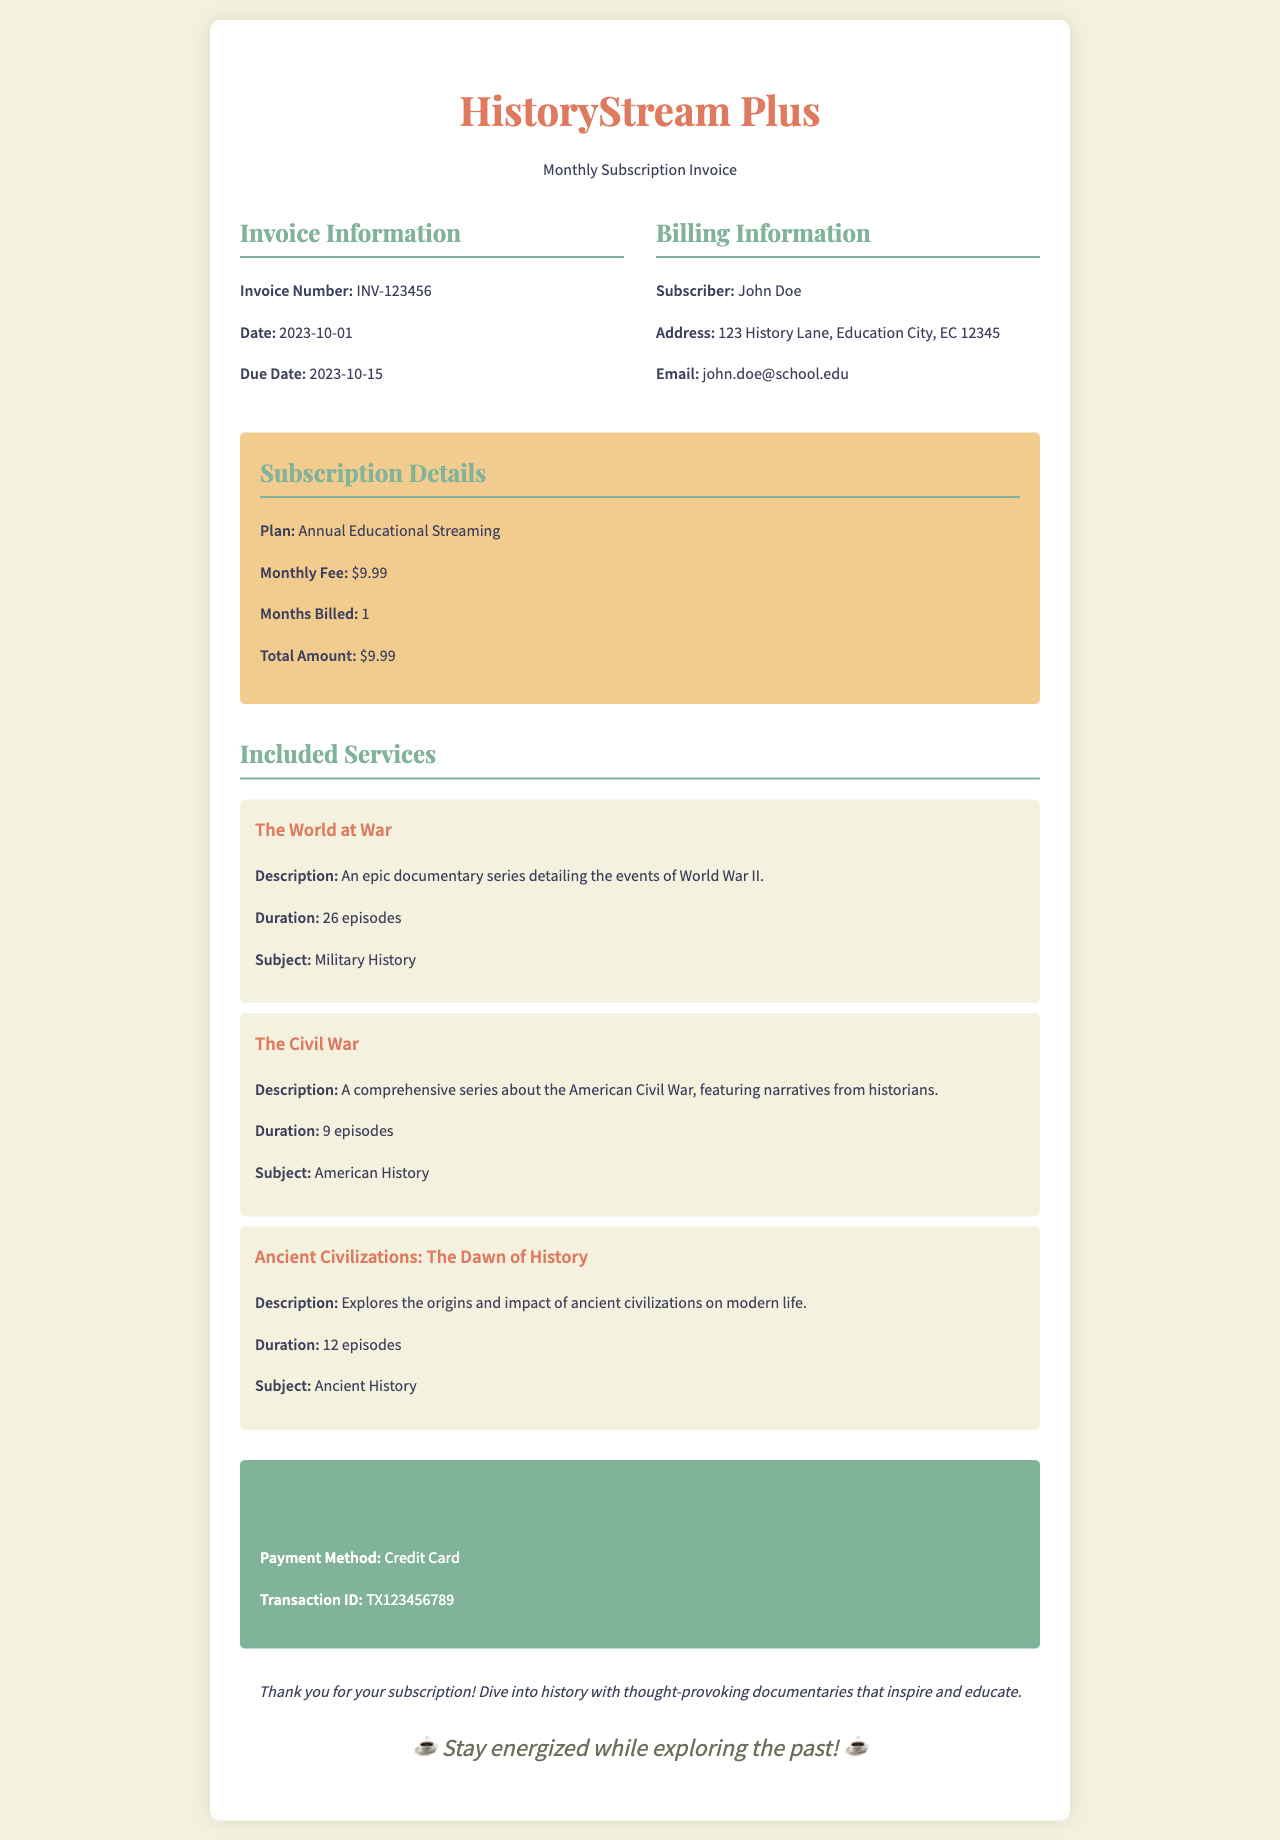What is the invoice number? The invoice number is a unique identifier for the invoice provided in the document.
Answer: INV-123456 What is the total amount due? The total amount due is stated in the subscription details section of the invoice.
Answer: $9.99 Who is the subscriber? The subscriber's name can be found in the billing information section.
Answer: John Doe What is the monthly fee for the subscription? The monthly fee is listed under the subscription details section.
Answer: $9.99 How many episodes are in "The Civil War"? The number of episodes for "The Civil War" series is specified in the included services section.
Answer: 9 episodes What is the payment method used? The payment method appears in the payment information section of the invoice.
Answer: Credit Card What is the due date for this invoice? The due date is mentioned in the invoice details section.
Answer: 2023-10-15 What documentary series features episodes on World War II? This series is indicated in the included services section of the invoice.
Answer: The World at War What is the transaction ID? The transaction ID is provided in the payment information section and serves as a record of the transaction.
Answer: TX123456 